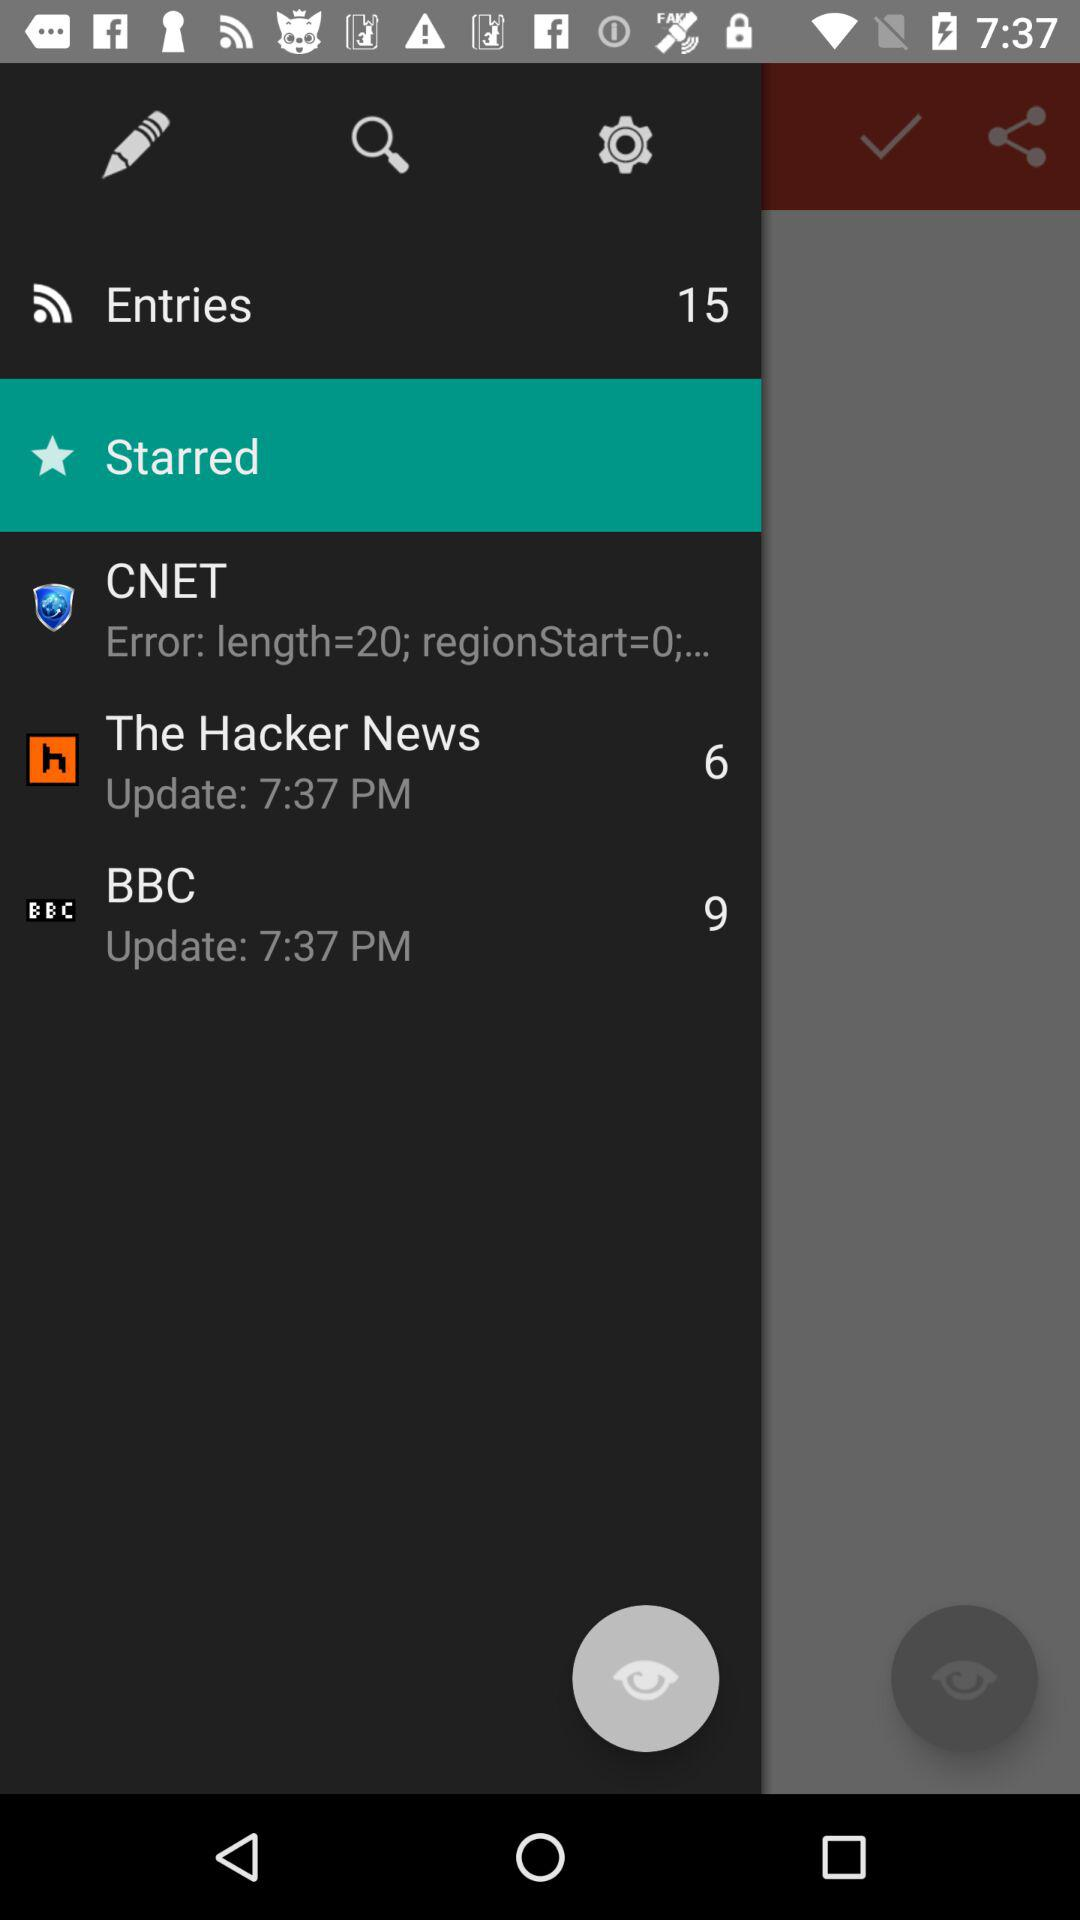At what time was "The Hacker News" updated? "The Hacker News" was updated at 7:37 p.m. 